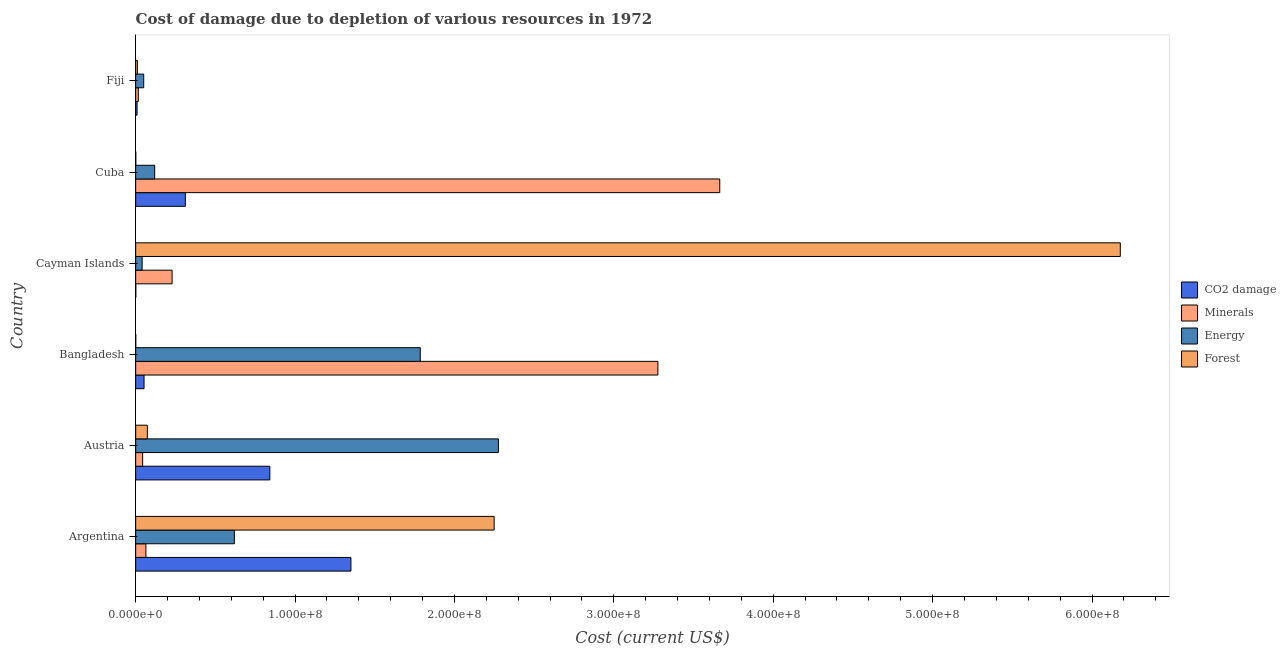How many different coloured bars are there?
Your answer should be compact. 4. How many groups of bars are there?
Keep it short and to the point. 6. Are the number of bars on each tick of the Y-axis equal?
Your answer should be compact. Yes. How many bars are there on the 5th tick from the top?
Offer a terse response. 4. How many bars are there on the 2nd tick from the bottom?
Give a very brief answer. 4. What is the cost of damage due to depletion of forests in Cuba?
Give a very brief answer. 5.68e+04. Across all countries, what is the maximum cost of damage due to depletion of minerals?
Provide a short and direct response. 3.66e+08. Across all countries, what is the minimum cost of damage due to depletion of minerals?
Your response must be concise. 1.66e+06. In which country was the cost of damage due to depletion of minerals maximum?
Offer a terse response. Cuba. In which country was the cost of damage due to depletion of coal minimum?
Ensure brevity in your answer.  Cayman Islands. What is the total cost of damage due to depletion of coal in the graph?
Provide a short and direct response. 2.57e+08. What is the difference between the cost of damage due to depletion of energy in Austria and that in Fiji?
Provide a short and direct response. 2.23e+08. What is the difference between the cost of damage due to depletion of forests in Argentina and the cost of damage due to depletion of coal in Cayman Islands?
Your response must be concise. 2.25e+08. What is the average cost of damage due to depletion of minerals per country?
Give a very brief answer. 1.22e+08. What is the difference between the cost of damage due to depletion of minerals and cost of damage due to depletion of energy in Austria?
Your answer should be very brief. -2.23e+08. What is the ratio of the cost of damage due to depletion of energy in Austria to that in Bangladesh?
Your answer should be compact. 1.27. Is the cost of damage due to depletion of minerals in Austria less than that in Cayman Islands?
Ensure brevity in your answer.  Yes. Is the difference between the cost of damage due to depletion of coal in Argentina and Cuba greater than the difference between the cost of damage due to depletion of energy in Argentina and Cuba?
Give a very brief answer. Yes. What is the difference between the highest and the second highest cost of damage due to depletion of forests?
Offer a very short reply. 3.93e+08. What is the difference between the highest and the lowest cost of damage due to depletion of coal?
Your answer should be very brief. 1.35e+08. What does the 2nd bar from the top in Argentina represents?
Offer a very short reply. Energy. What does the 2nd bar from the bottom in Bangladesh represents?
Offer a very short reply. Minerals. Is it the case that in every country, the sum of the cost of damage due to depletion of coal and cost of damage due to depletion of minerals is greater than the cost of damage due to depletion of energy?
Offer a terse response. No. Are all the bars in the graph horizontal?
Make the answer very short. Yes. How many countries are there in the graph?
Your answer should be very brief. 6. What is the difference between two consecutive major ticks on the X-axis?
Your answer should be compact. 1.00e+08. Does the graph contain any zero values?
Keep it short and to the point. No. Where does the legend appear in the graph?
Offer a terse response. Center right. How are the legend labels stacked?
Offer a very short reply. Vertical. What is the title of the graph?
Your answer should be compact. Cost of damage due to depletion of various resources in 1972 . What is the label or title of the X-axis?
Keep it short and to the point. Cost (current US$). What is the label or title of the Y-axis?
Offer a terse response. Country. What is the Cost (current US$) of CO2 damage in Argentina?
Offer a terse response. 1.35e+08. What is the Cost (current US$) of Minerals in Argentina?
Keep it short and to the point. 6.43e+06. What is the Cost (current US$) of Energy in Argentina?
Provide a succinct answer. 6.19e+07. What is the Cost (current US$) in Forest in Argentina?
Keep it short and to the point. 2.25e+08. What is the Cost (current US$) in CO2 damage in Austria?
Make the answer very short. 8.42e+07. What is the Cost (current US$) in Minerals in Austria?
Provide a succinct answer. 4.37e+06. What is the Cost (current US$) in Energy in Austria?
Offer a terse response. 2.28e+08. What is the Cost (current US$) of Forest in Austria?
Keep it short and to the point. 7.34e+06. What is the Cost (current US$) in CO2 damage in Bangladesh?
Your answer should be very brief. 5.26e+06. What is the Cost (current US$) of Minerals in Bangladesh?
Offer a terse response. 3.28e+08. What is the Cost (current US$) of Energy in Bangladesh?
Provide a short and direct response. 1.79e+08. What is the Cost (current US$) in Forest in Bangladesh?
Make the answer very short. 3.57e+04. What is the Cost (current US$) of CO2 damage in Cayman Islands?
Ensure brevity in your answer.  8.24e+04. What is the Cost (current US$) of Minerals in Cayman Islands?
Keep it short and to the point. 2.28e+07. What is the Cost (current US$) of Energy in Cayman Islands?
Make the answer very short. 4.05e+06. What is the Cost (current US$) in Forest in Cayman Islands?
Provide a succinct answer. 6.18e+08. What is the Cost (current US$) in CO2 damage in Cuba?
Ensure brevity in your answer.  3.12e+07. What is the Cost (current US$) in Minerals in Cuba?
Offer a very short reply. 3.66e+08. What is the Cost (current US$) of Energy in Cuba?
Make the answer very short. 1.19e+07. What is the Cost (current US$) of Forest in Cuba?
Your response must be concise. 5.68e+04. What is the Cost (current US$) in CO2 damage in Fiji?
Your answer should be compact. 8.68e+05. What is the Cost (current US$) in Minerals in Fiji?
Offer a terse response. 1.66e+06. What is the Cost (current US$) in Energy in Fiji?
Make the answer very short. 5.04e+06. What is the Cost (current US$) in Forest in Fiji?
Make the answer very short. 1.08e+06. Across all countries, what is the maximum Cost (current US$) of CO2 damage?
Give a very brief answer. 1.35e+08. Across all countries, what is the maximum Cost (current US$) of Minerals?
Offer a very short reply. 3.66e+08. Across all countries, what is the maximum Cost (current US$) in Energy?
Provide a succinct answer. 2.28e+08. Across all countries, what is the maximum Cost (current US$) of Forest?
Provide a short and direct response. 6.18e+08. Across all countries, what is the minimum Cost (current US$) in CO2 damage?
Ensure brevity in your answer.  8.24e+04. Across all countries, what is the minimum Cost (current US$) in Minerals?
Keep it short and to the point. 1.66e+06. Across all countries, what is the minimum Cost (current US$) of Energy?
Offer a terse response. 4.05e+06. Across all countries, what is the minimum Cost (current US$) in Forest?
Make the answer very short. 3.57e+04. What is the total Cost (current US$) in CO2 damage in the graph?
Your answer should be compact. 2.57e+08. What is the total Cost (current US$) in Minerals in the graph?
Offer a terse response. 7.29e+08. What is the total Cost (current US$) in Energy in the graph?
Provide a short and direct response. 4.89e+08. What is the total Cost (current US$) of Forest in the graph?
Ensure brevity in your answer.  8.51e+08. What is the difference between the Cost (current US$) of CO2 damage in Argentina and that in Austria?
Make the answer very short. 5.09e+07. What is the difference between the Cost (current US$) in Minerals in Argentina and that in Austria?
Your answer should be very brief. 2.06e+06. What is the difference between the Cost (current US$) of Energy in Argentina and that in Austria?
Offer a terse response. -1.66e+08. What is the difference between the Cost (current US$) of Forest in Argentina and that in Austria?
Your answer should be compact. 2.18e+08. What is the difference between the Cost (current US$) in CO2 damage in Argentina and that in Bangladesh?
Your response must be concise. 1.30e+08. What is the difference between the Cost (current US$) of Minerals in Argentina and that in Bangladesh?
Offer a very short reply. -3.21e+08. What is the difference between the Cost (current US$) in Energy in Argentina and that in Bangladesh?
Your response must be concise. -1.17e+08. What is the difference between the Cost (current US$) in Forest in Argentina and that in Bangladesh?
Offer a terse response. 2.25e+08. What is the difference between the Cost (current US$) in CO2 damage in Argentina and that in Cayman Islands?
Offer a terse response. 1.35e+08. What is the difference between the Cost (current US$) in Minerals in Argentina and that in Cayman Islands?
Your response must be concise. -1.64e+07. What is the difference between the Cost (current US$) in Energy in Argentina and that in Cayman Islands?
Make the answer very short. 5.79e+07. What is the difference between the Cost (current US$) of Forest in Argentina and that in Cayman Islands?
Your answer should be very brief. -3.93e+08. What is the difference between the Cost (current US$) in CO2 damage in Argentina and that in Cuba?
Offer a very short reply. 1.04e+08. What is the difference between the Cost (current US$) in Minerals in Argentina and that in Cuba?
Provide a short and direct response. -3.60e+08. What is the difference between the Cost (current US$) of Energy in Argentina and that in Cuba?
Your answer should be compact. 5.00e+07. What is the difference between the Cost (current US$) in Forest in Argentina and that in Cuba?
Keep it short and to the point. 2.25e+08. What is the difference between the Cost (current US$) in CO2 damage in Argentina and that in Fiji?
Make the answer very short. 1.34e+08. What is the difference between the Cost (current US$) of Minerals in Argentina and that in Fiji?
Make the answer very short. 4.77e+06. What is the difference between the Cost (current US$) in Energy in Argentina and that in Fiji?
Ensure brevity in your answer.  5.69e+07. What is the difference between the Cost (current US$) of Forest in Argentina and that in Fiji?
Give a very brief answer. 2.24e+08. What is the difference between the Cost (current US$) in CO2 damage in Austria and that in Bangladesh?
Your answer should be very brief. 7.89e+07. What is the difference between the Cost (current US$) of Minerals in Austria and that in Bangladesh?
Provide a succinct answer. -3.23e+08. What is the difference between the Cost (current US$) in Energy in Austria and that in Bangladesh?
Ensure brevity in your answer.  4.90e+07. What is the difference between the Cost (current US$) of Forest in Austria and that in Bangladesh?
Give a very brief answer. 7.31e+06. What is the difference between the Cost (current US$) of CO2 damage in Austria and that in Cayman Islands?
Your response must be concise. 8.41e+07. What is the difference between the Cost (current US$) in Minerals in Austria and that in Cayman Islands?
Provide a succinct answer. -1.85e+07. What is the difference between the Cost (current US$) of Energy in Austria and that in Cayman Islands?
Offer a very short reply. 2.24e+08. What is the difference between the Cost (current US$) of Forest in Austria and that in Cayman Islands?
Offer a terse response. -6.10e+08. What is the difference between the Cost (current US$) of CO2 damage in Austria and that in Cuba?
Your answer should be compact. 5.30e+07. What is the difference between the Cost (current US$) in Minerals in Austria and that in Cuba?
Keep it short and to the point. -3.62e+08. What is the difference between the Cost (current US$) of Energy in Austria and that in Cuba?
Ensure brevity in your answer.  2.16e+08. What is the difference between the Cost (current US$) in Forest in Austria and that in Cuba?
Make the answer very short. 7.29e+06. What is the difference between the Cost (current US$) of CO2 damage in Austria and that in Fiji?
Offer a very short reply. 8.33e+07. What is the difference between the Cost (current US$) of Minerals in Austria and that in Fiji?
Provide a succinct answer. 2.72e+06. What is the difference between the Cost (current US$) of Energy in Austria and that in Fiji?
Offer a terse response. 2.23e+08. What is the difference between the Cost (current US$) of Forest in Austria and that in Fiji?
Your answer should be compact. 6.26e+06. What is the difference between the Cost (current US$) in CO2 damage in Bangladesh and that in Cayman Islands?
Provide a succinct answer. 5.17e+06. What is the difference between the Cost (current US$) of Minerals in Bangladesh and that in Cayman Islands?
Your response must be concise. 3.05e+08. What is the difference between the Cost (current US$) of Energy in Bangladesh and that in Cayman Islands?
Give a very brief answer. 1.75e+08. What is the difference between the Cost (current US$) in Forest in Bangladesh and that in Cayman Islands?
Make the answer very short. -6.18e+08. What is the difference between the Cost (current US$) of CO2 damage in Bangladesh and that in Cuba?
Give a very brief answer. -2.59e+07. What is the difference between the Cost (current US$) of Minerals in Bangladesh and that in Cuba?
Your response must be concise. -3.88e+07. What is the difference between the Cost (current US$) in Energy in Bangladesh and that in Cuba?
Give a very brief answer. 1.67e+08. What is the difference between the Cost (current US$) of Forest in Bangladesh and that in Cuba?
Your response must be concise. -2.11e+04. What is the difference between the Cost (current US$) in CO2 damage in Bangladesh and that in Fiji?
Give a very brief answer. 4.39e+06. What is the difference between the Cost (current US$) in Minerals in Bangladesh and that in Fiji?
Your answer should be very brief. 3.26e+08. What is the difference between the Cost (current US$) of Energy in Bangladesh and that in Fiji?
Your answer should be compact. 1.74e+08. What is the difference between the Cost (current US$) of Forest in Bangladesh and that in Fiji?
Ensure brevity in your answer.  -1.04e+06. What is the difference between the Cost (current US$) of CO2 damage in Cayman Islands and that in Cuba?
Give a very brief answer. -3.11e+07. What is the difference between the Cost (current US$) in Minerals in Cayman Islands and that in Cuba?
Ensure brevity in your answer.  -3.44e+08. What is the difference between the Cost (current US$) in Energy in Cayman Islands and that in Cuba?
Your response must be concise. -7.89e+06. What is the difference between the Cost (current US$) of Forest in Cayman Islands and that in Cuba?
Make the answer very short. 6.18e+08. What is the difference between the Cost (current US$) in CO2 damage in Cayman Islands and that in Fiji?
Your response must be concise. -7.85e+05. What is the difference between the Cost (current US$) in Minerals in Cayman Islands and that in Fiji?
Make the answer very short. 2.12e+07. What is the difference between the Cost (current US$) in Energy in Cayman Islands and that in Fiji?
Your response must be concise. -9.94e+05. What is the difference between the Cost (current US$) in Forest in Cayman Islands and that in Fiji?
Provide a short and direct response. 6.17e+08. What is the difference between the Cost (current US$) of CO2 damage in Cuba and that in Fiji?
Your response must be concise. 3.03e+07. What is the difference between the Cost (current US$) of Minerals in Cuba and that in Fiji?
Your answer should be very brief. 3.65e+08. What is the difference between the Cost (current US$) in Energy in Cuba and that in Fiji?
Give a very brief answer. 6.89e+06. What is the difference between the Cost (current US$) in Forest in Cuba and that in Fiji?
Ensure brevity in your answer.  -1.02e+06. What is the difference between the Cost (current US$) in CO2 damage in Argentina and the Cost (current US$) in Minerals in Austria?
Offer a terse response. 1.31e+08. What is the difference between the Cost (current US$) in CO2 damage in Argentina and the Cost (current US$) in Energy in Austria?
Offer a very short reply. -9.25e+07. What is the difference between the Cost (current US$) in CO2 damage in Argentina and the Cost (current US$) in Forest in Austria?
Your response must be concise. 1.28e+08. What is the difference between the Cost (current US$) in Minerals in Argentina and the Cost (current US$) in Energy in Austria?
Keep it short and to the point. -2.21e+08. What is the difference between the Cost (current US$) in Minerals in Argentina and the Cost (current US$) in Forest in Austria?
Your response must be concise. -9.13e+05. What is the difference between the Cost (current US$) of Energy in Argentina and the Cost (current US$) of Forest in Austria?
Make the answer very short. 5.46e+07. What is the difference between the Cost (current US$) of CO2 damage in Argentina and the Cost (current US$) of Minerals in Bangladesh?
Make the answer very short. -1.93e+08. What is the difference between the Cost (current US$) in CO2 damage in Argentina and the Cost (current US$) in Energy in Bangladesh?
Ensure brevity in your answer.  -4.35e+07. What is the difference between the Cost (current US$) of CO2 damage in Argentina and the Cost (current US$) of Forest in Bangladesh?
Make the answer very short. 1.35e+08. What is the difference between the Cost (current US$) of Minerals in Argentina and the Cost (current US$) of Energy in Bangladesh?
Your answer should be compact. -1.72e+08. What is the difference between the Cost (current US$) in Minerals in Argentina and the Cost (current US$) in Forest in Bangladesh?
Ensure brevity in your answer.  6.39e+06. What is the difference between the Cost (current US$) of Energy in Argentina and the Cost (current US$) of Forest in Bangladesh?
Your answer should be very brief. 6.19e+07. What is the difference between the Cost (current US$) of CO2 damage in Argentina and the Cost (current US$) of Minerals in Cayman Islands?
Your answer should be compact. 1.12e+08. What is the difference between the Cost (current US$) in CO2 damage in Argentina and the Cost (current US$) in Energy in Cayman Islands?
Offer a terse response. 1.31e+08. What is the difference between the Cost (current US$) in CO2 damage in Argentina and the Cost (current US$) in Forest in Cayman Islands?
Offer a terse response. -4.83e+08. What is the difference between the Cost (current US$) in Minerals in Argentina and the Cost (current US$) in Energy in Cayman Islands?
Give a very brief answer. 2.38e+06. What is the difference between the Cost (current US$) in Minerals in Argentina and the Cost (current US$) in Forest in Cayman Islands?
Your answer should be compact. -6.11e+08. What is the difference between the Cost (current US$) of Energy in Argentina and the Cost (current US$) of Forest in Cayman Islands?
Your answer should be very brief. -5.56e+08. What is the difference between the Cost (current US$) in CO2 damage in Argentina and the Cost (current US$) in Minerals in Cuba?
Keep it short and to the point. -2.31e+08. What is the difference between the Cost (current US$) in CO2 damage in Argentina and the Cost (current US$) in Energy in Cuba?
Your response must be concise. 1.23e+08. What is the difference between the Cost (current US$) in CO2 damage in Argentina and the Cost (current US$) in Forest in Cuba?
Make the answer very short. 1.35e+08. What is the difference between the Cost (current US$) in Minerals in Argentina and the Cost (current US$) in Energy in Cuba?
Make the answer very short. -5.50e+06. What is the difference between the Cost (current US$) in Minerals in Argentina and the Cost (current US$) in Forest in Cuba?
Provide a short and direct response. 6.37e+06. What is the difference between the Cost (current US$) of Energy in Argentina and the Cost (current US$) of Forest in Cuba?
Provide a short and direct response. 6.19e+07. What is the difference between the Cost (current US$) in CO2 damage in Argentina and the Cost (current US$) in Minerals in Fiji?
Your answer should be compact. 1.33e+08. What is the difference between the Cost (current US$) of CO2 damage in Argentina and the Cost (current US$) of Energy in Fiji?
Offer a terse response. 1.30e+08. What is the difference between the Cost (current US$) of CO2 damage in Argentina and the Cost (current US$) of Forest in Fiji?
Provide a succinct answer. 1.34e+08. What is the difference between the Cost (current US$) in Minerals in Argentina and the Cost (current US$) in Energy in Fiji?
Offer a terse response. 1.39e+06. What is the difference between the Cost (current US$) of Minerals in Argentina and the Cost (current US$) of Forest in Fiji?
Provide a short and direct response. 5.35e+06. What is the difference between the Cost (current US$) of Energy in Argentina and the Cost (current US$) of Forest in Fiji?
Provide a succinct answer. 6.08e+07. What is the difference between the Cost (current US$) in CO2 damage in Austria and the Cost (current US$) in Minerals in Bangladesh?
Give a very brief answer. -2.43e+08. What is the difference between the Cost (current US$) in CO2 damage in Austria and the Cost (current US$) in Energy in Bangladesh?
Ensure brevity in your answer.  -9.44e+07. What is the difference between the Cost (current US$) of CO2 damage in Austria and the Cost (current US$) of Forest in Bangladesh?
Provide a short and direct response. 8.41e+07. What is the difference between the Cost (current US$) in Minerals in Austria and the Cost (current US$) in Energy in Bangladesh?
Your answer should be compact. -1.74e+08. What is the difference between the Cost (current US$) in Minerals in Austria and the Cost (current US$) in Forest in Bangladesh?
Offer a terse response. 4.34e+06. What is the difference between the Cost (current US$) of Energy in Austria and the Cost (current US$) of Forest in Bangladesh?
Keep it short and to the point. 2.28e+08. What is the difference between the Cost (current US$) in CO2 damage in Austria and the Cost (current US$) in Minerals in Cayman Islands?
Give a very brief answer. 6.13e+07. What is the difference between the Cost (current US$) in CO2 damage in Austria and the Cost (current US$) in Energy in Cayman Islands?
Provide a succinct answer. 8.01e+07. What is the difference between the Cost (current US$) in CO2 damage in Austria and the Cost (current US$) in Forest in Cayman Islands?
Your response must be concise. -5.34e+08. What is the difference between the Cost (current US$) in Minerals in Austria and the Cost (current US$) in Energy in Cayman Islands?
Make the answer very short. 3.25e+05. What is the difference between the Cost (current US$) of Minerals in Austria and the Cost (current US$) of Forest in Cayman Islands?
Keep it short and to the point. -6.13e+08. What is the difference between the Cost (current US$) of Energy in Austria and the Cost (current US$) of Forest in Cayman Islands?
Make the answer very short. -3.90e+08. What is the difference between the Cost (current US$) of CO2 damage in Austria and the Cost (current US$) of Minerals in Cuba?
Ensure brevity in your answer.  -2.82e+08. What is the difference between the Cost (current US$) in CO2 damage in Austria and the Cost (current US$) in Energy in Cuba?
Offer a terse response. 7.22e+07. What is the difference between the Cost (current US$) of CO2 damage in Austria and the Cost (current US$) of Forest in Cuba?
Provide a succinct answer. 8.41e+07. What is the difference between the Cost (current US$) in Minerals in Austria and the Cost (current US$) in Energy in Cuba?
Offer a terse response. -7.56e+06. What is the difference between the Cost (current US$) of Minerals in Austria and the Cost (current US$) of Forest in Cuba?
Your response must be concise. 4.32e+06. What is the difference between the Cost (current US$) in Energy in Austria and the Cost (current US$) in Forest in Cuba?
Keep it short and to the point. 2.28e+08. What is the difference between the Cost (current US$) of CO2 damage in Austria and the Cost (current US$) of Minerals in Fiji?
Offer a very short reply. 8.25e+07. What is the difference between the Cost (current US$) in CO2 damage in Austria and the Cost (current US$) in Energy in Fiji?
Your answer should be very brief. 7.91e+07. What is the difference between the Cost (current US$) of CO2 damage in Austria and the Cost (current US$) of Forest in Fiji?
Give a very brief answer. 8.31e+07. What is the difference between the Cost (current US$) in Minerals in Austria and the Cost (current US$) in Energy in Fiji?
Your answer should be compact. -6.68e+05. What is the difference between the Cost (current US$) in Minerals in Austria and the Cost (current US$) in Forest in Fiji?
Keep it short and to the point. 3.29e+06. What is the difference between the Cost (current US$) of Energy in Austria and the Cost (current US$) of Forest in Fiji?
Your answer should be compact. 2.27e+08. What is the difference between the Cost (current US$) of CO2 damage in Bangladesh and the Cost (current US$) of Minerals in Cayman Islands?
Your response must be concise. -1.76e+07. What is the difference between the Cost (current US$) of CO2 damage in Bangladesh and the Cost (current US$) of Energy in Cayman Islands?
Your answer should be compact. 1.21e+06. What is the difference between the Cost (current US$) in CO2 damage in Bangladesh and the Cost (current US$) in Forest in Cayman Islands?
Provide a succinct answer. -6.12e+08. What is the difference between the Cost (current US$) of Minerals in Bangladesh and the Cost (current US$) of Energy in Cayman Islands?
Provide a short and direct response. 3.24e+08. What is the difference between the Cost (current US$) in Minerals in Bangladesh and the Cost (current US$) in Forest in Cayman Islands?
Give a very brief answer. -2.90e+08. What is the difference between the Cost (current US$) of Energy in Bangladesh and the Cost (current US$) of Forest in Cayman Islands?
Your answer should be very brief. -4.39e+08. What is the difference between the Cost (current US$) in CO2 damage in Bangladesh and the Cost (current US$) in Minerals in Cuba?
Make the answer very short. -3.61e+08. What is the difference between the Cost (current US$) in CO2 damage in Bangladesh and the Cost (current US$) in Energy in Cuba?
Your answer should be compact. -6.68e+06. What is the difference between the Cost (current US$) of CO2 damage in Bangladesh and the Cost (current US$) of Forest in Cuba?
Give a very brief answer. 5.20e+06. What is the difference between the Cost (current US$) of Minerals in Bangladesh and the Cost (current US$) of Energy in Cuba?
Provide a short and direct response. 3.16e+08. What is the difference between the Cost (current US$) in Minerals in Bangladesh and the Cost (current US$) in Forest in Cuba?
Provide a short and direct response. 3.28e+08. What is the difference between the Cost (current US$) of Energy in Bangladesh and the Cost (current US$) of Forest in Cuba?
Your response must be concise. 1.79e+08. What is the difference between the Cost (current US$) of CO2 damage in Bangladesh and the Cost (current US$) of Minerals in Fiji?
Your answer should be very brief. 3.60e+06. What is the difference between the Cost (current US$) in CO2 damage in Bangladesh and the Cost (current US$) in Energy in Fiji?
Your response must be concise. 2.16e+05. What is the difference between the Cost (current US$) of CO2 damage in Bangladesh and the Cost (current US$) of Forest in Fiji?
Ensure brevity in your answer.  4.18e+06. What is the difference between the Cost (current US$) in Minerals in Bangladesh and the Cost (current US$) in Energy in Fiji?
Give a very brief answer. 3.23e+08. What is the difference between the Cost (current US$) in Minerals in Bangladesh and the Cost (current US$) in Forest in Fiji?
Your answer should be compact. 3.27e+08. What is the difference between the Cost (current US$) in Energy in Bangladesh and the Cost (current US$) in Forest in Fiji?
Make the answer very short. 1.77e+08. What is the difference between the Cost (current US$) in CO2 damage in Cayman Islands and the Cost (current US$) in Minerals in Cuba?
Offer a very short reply. -3.66e+08. What is the difference between the Cost (current US$) of CO2 damage in Cayman Islands and the Cost (current US$) of Energy in Cuba?
Your answer should be very brief. -1.19e+07. What is the difference between the Cost (current US$) of CO2 damage in Cayman Islands and the Cost (current US$) of Forest in Cuba?
Your response must be concise. 2.56e+04. What is the difference between the Cost (current US$) of Minerals in Cayman Islands and the Cost (current US$) of Energy in Cuba?
Your response must be concise. 1.09e+07. What is the difference between the Cost (current US$) of Minerals in Cayman Islands and the Cost (current US$) of Forest in Cuba?
Your response must be concise. 2.28e+07. What is the difference between the Cost (current US$) of Energy in Cayman Islands and the Cost (current US$) of Forest in Cuba?
Keep it short and to the point. 3.99e+06. What is the difference between the Cost (current US$) in CO2 damage in Cayman Islands and the Cost (current US$) in Minerals in Fiji?
Offer a very short reply. -1.57e+06. What is the difference between the Cost (current US$) in CO2 damage in Cayman Islands and the Cost (current US$) in Energy in Fiji?
Offer a very short reply. -4.96e+06. What is the difference between the Cost (current US$) of CO2 damage in Cayman Islands and the Cost (current US$) of Forest in Fiji?
Your answer should be very brief. -9.96e+05. What is the difference between the Cost (current US$) of Minerals in Cayman Islands and the Cost (current US$) of Energy in Fiji?
Ensure brevity in your answer.  1.78e+07. What is the difference between the Cost (current US$) of Minerals in Cayman Islands and the Cost (current US$) of Forest in Fiji?
Offer a very short reply. 2.18e+07. What is the difference between the Cost (current US$) of Energy in Cayman Islands and the Cost (current US$) of Forest in Fiji?
Provide a short and direct response. 2.97e+06. What is the difference between the Cost (current US$) of CO2 damage in Cuba and the Cost (current US$) of Minerals in Fiji?
Keep it short and to the point. 2.95e+07. What is the difference between the Cost (current US$) in CO2 damage in Cuba and the Cost (current US$) in Energy in Fiji?
Offer a very short reply. 2.61e+07. What is the difference between the Cost (current US$) in CO2 damage in Cuba and the Cost (current US$) in Forest in Fiji?
Give a very brief answer. 3.01e+07. What is the difference between the Cost (current US$) in Minerals in Cuba and the Cost (current US$) in Energy in Fiji?
Offer a very short reply. 3.61e+08. What is the difference between the Cost (current US$) of Minerals in Cuba and the Cost (current US$) of Forest in Fiji?
Your answer should be compact. 3.65e+08. What is the difference between the Cost (current US$) of Energy in Cuba and the Cost (current US$) of Forest in Fiji?
Your answer should be compact. 1.09e+07. What is the average Cost (current US$) in CO2 damage per country?
Offer a very short reply. 4.28e+07. What is the average Cost (current US$) in Minerals per country?
Your answer should be very brief. 1.22e+08. What is the average Cost (current US$) of Energy per country?
Your answer should be very brief. 8.15e+07. What is the average Cost (current US$) of Forest per country?
Provide a succinct answer. 1.42e+08. What is the difference between the Cost (current US$) of CO2 damage and Cost (current US$) of Minerals in Argentina?
Make the answer very short. 1.29e+08. What is the difference between the Cost (current US$) of CO2 damage and Cost (current US$) of Energy in Argentina?
Your answer should be compact. 7.31e+07. What is the difference between the Cost (current US$) of CO2 damage and Cost (current US$) of Forest in Argentina?
Your answer should be very brief. -8.99e+07. What is the difference between the Cost (current US$) of Minerals and Cost (current US$) of Energy in Argentina?
Your answer should be compact. -5.55e+07. What is the difference between the Cost (current US$) of Minerals and Cost (current US$) of Forest in Argentina?
Your response must be concise. -2.18e+08. What is the difference between the Cost (current US$) in Energy and Cost (current US$) in Forest in Argentina?
Your response must be concise. -1.63e+08. What is the difference between the Cost (current US$) of CO2 damage and Cost (current US$) of Minerals in Austria?
Keep it short and to the point. 7.98e+07. What is the difference between the Cost (current US$) in CO2 damage and Cost (current US$) in Energy in Austria?
Your answer should be very brief. -1.43e+08. What is the difference between the Cost (current US$) of CO2 damage and Cost (current US$) of Forest in Austria?
Your answer should be very brief. 7.68e+07. What is the difference between the Cost (current US$) of Minerals and Cost (current US$) of Energy in Austria?
Your answer should be compact. -2.23e+08. What is the difference between the Cost (current US$) in Minerals and Cost (current US$) in Forest in Austria?
Keep it short and to the point. -2.97e+06. What is the difference between the Cost (current US$) in Energy and Cost (current US$) in Forest in Austria?
Your response must be concise. 2.20e+08. What is the difference between the Cost (current US$) of CO2 damage and Cost (current US$) of Minerals in Bangladesh?
Offer a very short reply. -3.22e+08. What is the difference between the Cost (current US$) of CO2 damage and Cost (current US$) of Energy in Bangladesh?
Provide a short and direct response. -1.73e+08. What is the difference between the Cost (current US$) in CO2 damage and Cost (current US$) in Forest in Bangladesh?
Your answer should be very brief. 5.22e+06. What is the difference between the Cost (current US$) of Minerals and Cost (current US$) of Energy in Bangladesh?
Your answer should be very brief. 1.49e+08. What is the difference between the Cost (current US$) in Minerals and Cost (current US$) in Forest in Bangladesh?
Keep it short and to the point. 3.28e+08. What is the difference between the Cost (current US$) in Energy and Cost (current US$) in Forest in Bangladesh?
Ensure brevity in your answer.  1.79e+08. What is the difference between the Cost (current US$) in CO2 damage and Cost (current US$) in Minerals in Cayman Islands?
Provide a short and direct response. -2.28e+07. What is the difference between the Cost (current US$) in CO2 damage and Cost (current US$) in Energy in Cayman Islands?
Your response must be concise. -3.96e+06. What is the difference between the Cost (current US$) of CO2 damage and Cost (current US$) of Forest in Cayman Islands?
Offer a very short reply. -6.18e+08. What is the difference between the Cost (current US$) of Minerals and Cost (current US$) of Energy in Cayman Islands?
Ensure brevity in your answer.  1.88e+07. What is the difference between the Cost (current US$) of Minerals and Cost (current US$) of Forest in Cayman Islands?
Your response must be concise. -5.95e+08. What is the difference between the Cost (current US$) of Energy and Cost (current US$) of Forest in Cayman Islands?
Your answer should be compact. -6.14e+08. What is the difference between the Cost (current US$) of CO2 damage and Cost (current US$) of Minerals in Cuba?
Provide a succinct answer. -3.35e+08. What is the difference between the Cost (current US$) of CO2 damage and Cost (current US$) of Energy in Cuba?
Your answer should be very brief. 1.92e+07. What is the difference between the Cost (current US$) in CO2 damage and Cost (current US$) in Forest in Cuba?
Make the answer very short. 3.11e+07. What is the difference between the Cost (current US$) of Minerals and Cost (current US$) of Energy in Cuba?
Provide a succinct answer. 3.55e+08. What is the difference between the Cost (current US$) of Minerals and Cost (current US$) of Forest in Cuba?
Offer a very short reply. 3.66e+08. What is the difference between the Cost (current US$) in Energy and Cost (current US$) in Forest in Cuba?
Provide a succinct answer. 1.19e+07. What is the difference between the Cost (current US$) of CO2 damage and Cost (current US$) of Minerals in Fiji?
Provide a short and direct response. -7.88e+05. What is the difference between the Cost (current US$) of CO2 damage and Cost (current US$) of Energy in Fiji?
Keep it short and to the point. -4.17e+06. What is the difference between the Cost (current US$) in CO2 damage and Cost (current US$) in Forest in Fiji?
Offer a very short reply. -2.10e+05. What is the difference between the Cost (current US$) in Minerals and Cost (current US$) in Energy in Fiji?
Keep it short and to the point. -3.38e+06. What is the difference between the Cost (current US$) in Minerals and Cost (current US$) in Forest in Fiji?
Ensure brevity in your answer.  5.78e+05. What is the difference between the Cost (current US$) in Energy and Cost (current US$) in Forest in Fiji?
Provide a short and direct response. 3.96e+06. What is the ratio of the Cost (current US$) in CO2 damage in Argentina to that in Austria?
Provide a short and direct response. 1.6. What is the ratio of the Cost (current US$) in Minerals in Argentina to that in Austria?
Ensure brevity in your answer.  1.47. What is the ratio of the Cost (current US$) of Energy in Argentina to that in Austria?
Keep it short and to the point. 0.27. What is the ratio of the Cost (current US$) in Forest in Argentina to that in Austria?
Provide a succinct answer. 30.63. What is the ratio of the Cost (current US$) of CO2 damage in Argentina to that in Bangladesh?
Offer a terse response. 25.69. What is the ratio of the Cost (current US$) of Minerals in Argentina to that in Bangladesh?
Make the answer very short. 0.02. What is the ratio of the Cost (current US$) in Energy in Argentina to that in Bangladesh?
Your answer should be very brief. 0.35. What is the ratio of the Cost (current US$) of Forest in Argentina to that in Bangladesh?
Ensure brevity in your answer.  6303.23. What is the ratio of the Cost (current US$) in CO2 damage in Argentina to that in Cayman Islands?
Provide a short and direct response. 1639.07. What is the ratio of the Cost (current US$) of Minerals in Argentina to that in Cayman Islands?
Your answer should be very brief. 0.28. What is the ratio of the Cost (current US$) in Energy in Argentina to that in Cayman Islands?
Provide a succinct answer. 15.3. What is the ratio of the Cost (current US$) in Forest in Argentina to that in Cayman Islands?
Provide a succinct answer. 0.36. What is the ratio of the Cost (current US$) in CO2 damage in Argentina to that in Cuba?
Make the answer very short. 4.33. What is the ratio of the Cost (current US$) of Minerals in Argentina to that in Cuba?
Keep it short and to the point. 0.02. What is the ratio of the Cost (current US$) of Energy in Argentina to that in Cuba?
Give a very brief answer. 5.19. What is the ratio of the Cost (current US$) of Forest in Argentina to that in Cuba?
Offer a very short reply. 3957.92. What is the ratio of the Cost (current US$) in CO2 damage in Argentina to that in Fiji?
Offer a very short reply. 155.61. What is the ratio of the Cost (current US$) of Minerals in Argentina to that in Fiji?
Provide a short and direct response. 3.88. What is the ratio of the Cost (current US$) of Energy in Argentina to that in Fiji?
Your response must be concise. 12.28. What is the ratio of the Cost (current US$) of Forest in Argentina to that in Fiji?
Keep it short and to the point. 208.65. What is the ratio of the Cost (current US$) in CO2 damage in Austria to that in Bangladesh?
Your answer should be very brief. 16.01. What is the ratio of the Cost (current US$) in Minerals in Austria to that in Bangladesh?
Make the answer very short. 0.01. What is the ratio of the Cost (current US$) in Energy in Austria to that in Bangladesh?
Keep it short and to the point. 1.27. What is the ratio of the Cost (current US$) in Forest in Austria to that in Bangladesh?
Make the answer very short. 205.78. What is the ratio of the Cost (current US$) in CO2 damage in Austria to that in Cayman Islands?
Offer a very short reply. 1021.6. What is the ratio of the Cost (current US$) of Minerals in Austria to that in Cayman Islands?
Give a very brief answer. 0.19. What is the ratio of the Cost (current US$) of Energy in Austria to that in Cayman Islands?
Keep it short and to the point. 56.24. What is the ratio of the Cost (current US$) in Forest in Austria to that in Cayman Islands?
Ensure brevity in your answer.  0.01. What is the ratio of the Cost (current US$) of CO2 damage in Austria to that in Cuba?
Your answer should be compact. 2.7. What is the ratio of the Cost (current US$) in Minerals in Austria to that in Cuba?
Your answer should be very brief. 0.01. What is the ratio of the Cost (current US$) of Energy in Austria to that in Cuba?
Your answer should be compact. 19.07. What is the ratio of the Cost (current US$) of Forest in Austria to that in Cuba?
Make the answer very short. 129.21. What is the ratio of the Cost (current US$) of CO2 damage in Austria to that in Fiji?
Your response must be concise. 96.99. What is the ratio of the Cost (current US$) of Minerals in Austria to that in Fiji?
Provide a succinct answer. 2.64. What is the ratio of the Cost (current US$) in Energy in Austria to that in Fiji?
Your response must be concise. 45.15. What is the ratio of the Cost (current US$) of Forest in Austria to that in Fiji?
Your answer should be compact. 6.81. What is the ratio of the Cost (current US$) of CO2 damage in Bangladesh to that in Cayman Islands?
Make the answer very short. 63.8. What is the ratio of the Cost (current US$) in Minerals in Bangladesh to that in Cayman Islands?
Make the answer very short. 14.34. What is the ratio of the Cost (current US$) of Energy in Bangladesh to that in Cayman Islands?
Keep it short and to the point. 44.12. What is the ratio of the Cost (current US$) of CO2 damage in Bangladesh to that in Cuba?
Keep it short and to the point. 0.17. What is the ratio of the Cost (current US$) of Minerals in Bangladesh to that in Cuba?
Provide a short and direct response. 0.89. What is the ratio of the Cost (current US$) of Energy in Bangladesh to that in Cuba?
Offer a very short reply. 14.96. What is the ratio of the Cost (current US$) in Forest in Bangladesh to that in Cuba?
Your answer should be compact. 0.63. What is the ratio of the Cost (current US$) in CO2 damage in Bangladesh to that in Fiji?
Give a very brief answer. 6.06. What is the ratio of the Cost (current US$) of Minerals in Bangladesh to that in Fiji?
Make the answer very short. 197.85. What is the ratio of the Cost (current US$) of Energy in Bangladesh to that in Fiji?
Provide a short and direct response. 35.42. What is the ratio of the Cost (current US$) in Forest in Bangladesh to that in Fiji?
Give a very brief answer. 0.03. What is the ratio of the Cost (current US$) of CO2 damage in Cayman Islands to that in Cuba?
Offer a terse response. 0. What is the ratio of the Cost (current US$) in Minerals in Cayman Islands to that in Cuba?
Provide a short and direct response. 0.06. What is the ratio of the Cost (current US$) of Energy in Cayman Islands to that in Cuba?
Make the answer very short. 0.34. What is the ratio of the Cost (current US$) of Forest in Cayman Islands to that in Cuba?
Your answer should be compact. 1.09e+04. What is the ratio of the Cost (current US$) in CO2 damage in Cayman Islands to that in Fiji?
Your answer should be very brief. 0.09. What is the ratio of the Cost (current US$) of Minerals in Cayman Islands to that in Fiji?
Your answer should be compact. 13.8. What is the ratio of the Cost (current US$) in Energy in Cayman Islands to that in Fiji?
Give a very brief answer. 0.8. What is the ratio of the Cost (current US$) of Forest in Cayman Islands to that in Fiji?
Offer a terse response. 573.07. What is the ratio of the Cost (current US$) of CO2 damage in Cuba to that in Fiji?
Provide a short and direct response. 35.9. What is the ratio of the Cost (current US$) of Minerals in Cuba to that in Fiji?
Provide a short and direct response. 221.28. What is the ratio of the Cost (current US$) of Energy in Cuba to that in Fiji?
Your response must be concise. 2.37. What is the ratio of the Cost (current US$) of Forest in Cuba to that in Fiji?
Your answer should be very brief. 0.05. What is the difference between the highest and the second highest Cost (current US$) in CO2 damage?
Offer a very short reply. 5.09e+07. What is the difference between the highest and the second highest Cost (current US$) of Minerals?
Provide a succinct answer. 3.88e+07. What is the difference between the highest and the second highest Cost (current US$) of Energy?
Provide a short and direct response. 4.90e+07. What is the difference between the highest and the second highest Cost (current US$) of Forest?
Keep it short and to the point. 3.93e+08. What is the difference between the highest and the lowest Cost (current US$) of CO2 damage?
Make the answer very short. 1.35e+08. What is the difference between the highest and the lowest Cost (current US$) of Minerals?
Make the answer very short. 3.65e+08. What is the difference between the highest and the lowest Cost (current US$) in Energy?
Your answer should be compact. 2.24e+08. What is the difference between the highest and the lowest Cost (current US$) in Forest?
Your answer should be very brief. 6.18e+08. 